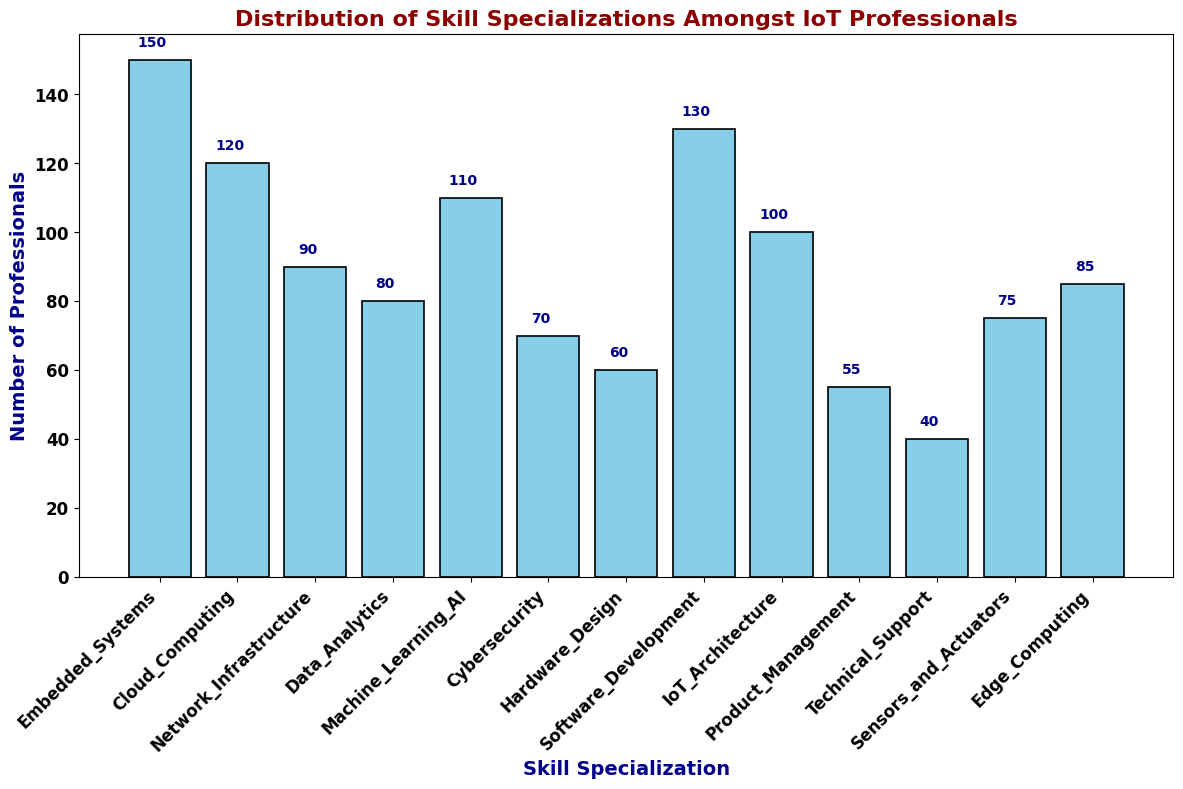Which skill specialization has the highest number of professionals? To find the skill specialization with the highest number of professionals, locate the tallest bar in the histogram. The bar labeled 'Embedded Systems' is the tallest, representing 150 professionals.
Answer: Embedded Systems What is the total number of professionals in Data Analytics and Machine Learning & AI? Add the number of professionals in Data Analytics (80) to the number of professionals in Machine Learning & AI (110). 80 + 110 = 190
Answer: 190 Which skill specialization has fewer professionals, Cybersecurity or Technical Support? Compare the heights of the bars for Cybersecurity and Technical Support. The bar for Technical Support is shorter, representing 40 professionals, whereas Cybersecurity has 70.
Answer: Technical Support What is the difference in the number of professionals between Software Development and Hardware Design? Subtract the number of professionals in Hardware Design (60) from Software Development (130). 130 - 60 = 70
Answer: 70 Which skill specialization has the least number of professionals? Identify the bar that is the shortest in the histogram. The shortest bar is labeled 'Technical Support', representing 40 professionals.
Answer: Technical Support How many more professionals specialize in Cloud Computing compared to Network Infrastructure? Subtract the number of professionals in Network Infrastructure (90) from Cloud Computing (120). 120 - 90 = 30
Answer: 30 What is the average number of professionals across all skill specializations? Sum the number of professionals in all skill specializations and divide by the number of specializations: (150 + 120 + 90 + 80 + 110 + 70 + 60 + 130 + 100 + 55 + 40 + 75 + 85) / 13. The total sum is 1165, so the average is 1165 / 13 ≈ 89.62
Answer: 89.62 How many skill specializations have more than 100 professionals? Count the number of bars taller than the line marking 100 professionals. These are Embedded Systems (150), Cloud Computing (120), Machine Learning & AI (110), and Software Development (130). There are 4 such specializations.
Answer: 4 What's the sum of professionals in Embedded Systems, Cloud Computing, and IoT Architecture? Add the number of professionals in Embedded Systems (150), Cloud Computing (120), and IoT Architecture (100). 150 + 120 + 100 = 370
Answer: 370 